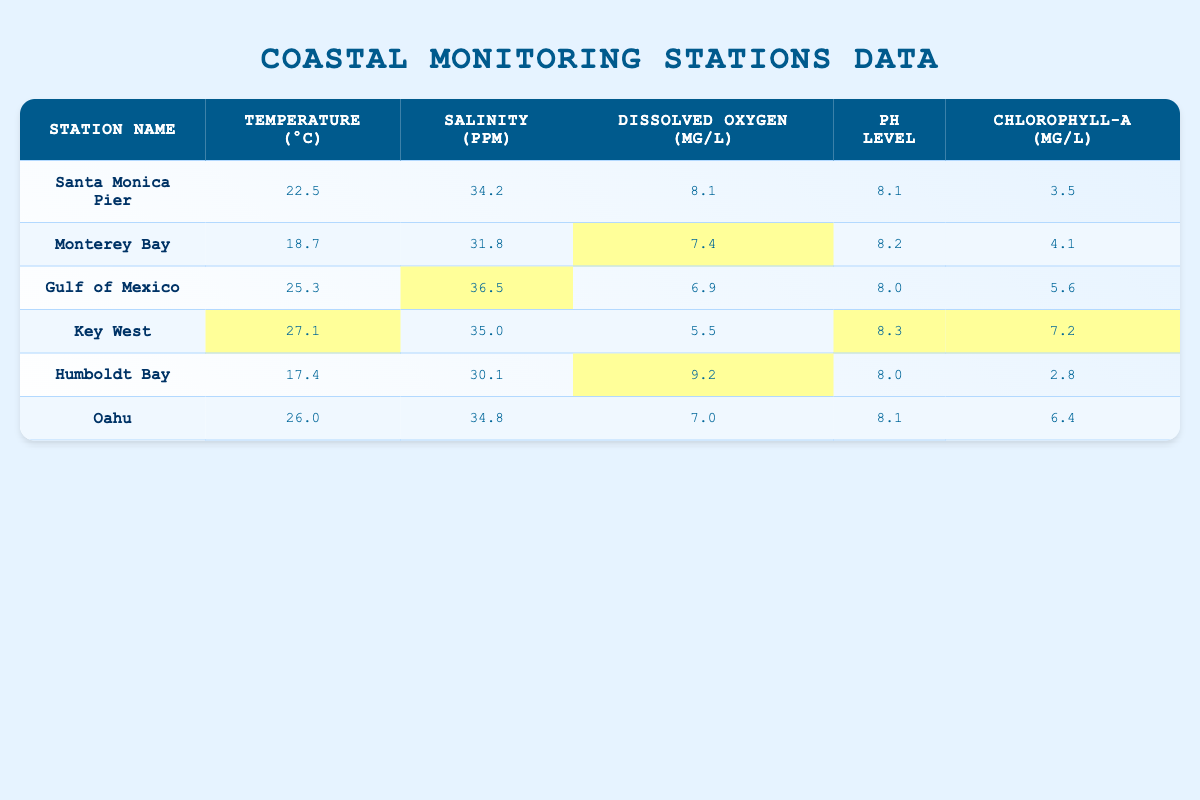What is the highest temperature recorded among the stations? By examining the temperature column for each station, the highest value is 27.1°C at Key West.
Answer: 27.1°C What is the dissolved oxygen level at Humboldt Bay? The dissolved oxygen level specifically for Humboldt Bay is listed as 9.2 mg/L.
Answer: 9.2 mg/L Which station has the lowest salinity? Comparing salinity levels, Monterey Bay has the lowest recorded salinity at 31.8 ppm.
Answer: 31.8 ppm What is the average chlorophyll-a concentration across all stations? To find the average, sum the chlorophyll-a values (3.5 + 4.1 + 5.6 + 7.2 + 2.8 + 6.4 = 29.6) and divide by the number of stations (6). So, the average is 29.6/6 = 4.93.
Answer: 4.93 μg/L Is the pH level at Oahu above 8? The pH level at Oahu is stated as 8.1, which is indeed above 8.
Answer: Yes What is the temperature difference between the hottest and the coldest stations? The hottest station is Key West at 27.1°C, and the coldest is Monterey Bay at 18.7°C. The difference is 27.1 - 18.7 = 8.4°C.
Answer: 8.4°C Which station has the highest chlorophyll-a concentration, and what is that value? Key West has the highest chlorophyll-a concentration at 7.2 μg/L, as compared to the other stations.
Answer: 7.2 μg/L Does any station report a dissolved oxygen level below 7 mg/L? Review the dissolved oxygen values: Gulf of Mexico (6.9 mg/L) and Key West (5.5 mg/L) reported values below 7 mg/L, so the answer is yes.
Answer: Yes What is the average pH level among all stations? Adding up the pH values (8.1 + 8.2 + 8.0 + 8.3 + 8.0 + 8.1) gives 48.7. Dividing by 6 results in an average pH level of 48.7/6 = 8.12.
Answer: 8.12 